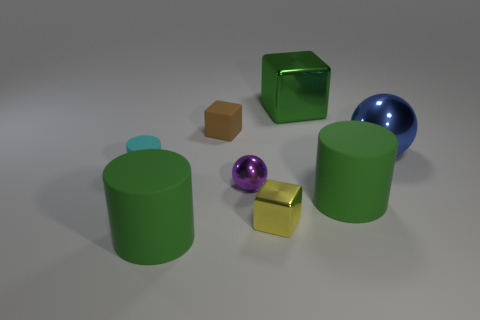Add 2 small purple metal things. How many objects exist? 10 Subtract all spheres. How many objects are left? 6 Subtract all big gray shiny things. Subtract all metal objects. How many objects are left? 4 Add 4 small yellow shiny blocks. How many small yellow shiny blocks are left? 5 Add 7 large spheres. How many large spheres exist? 8 Subtract 0 brown spheres. How many objects are left? 8 